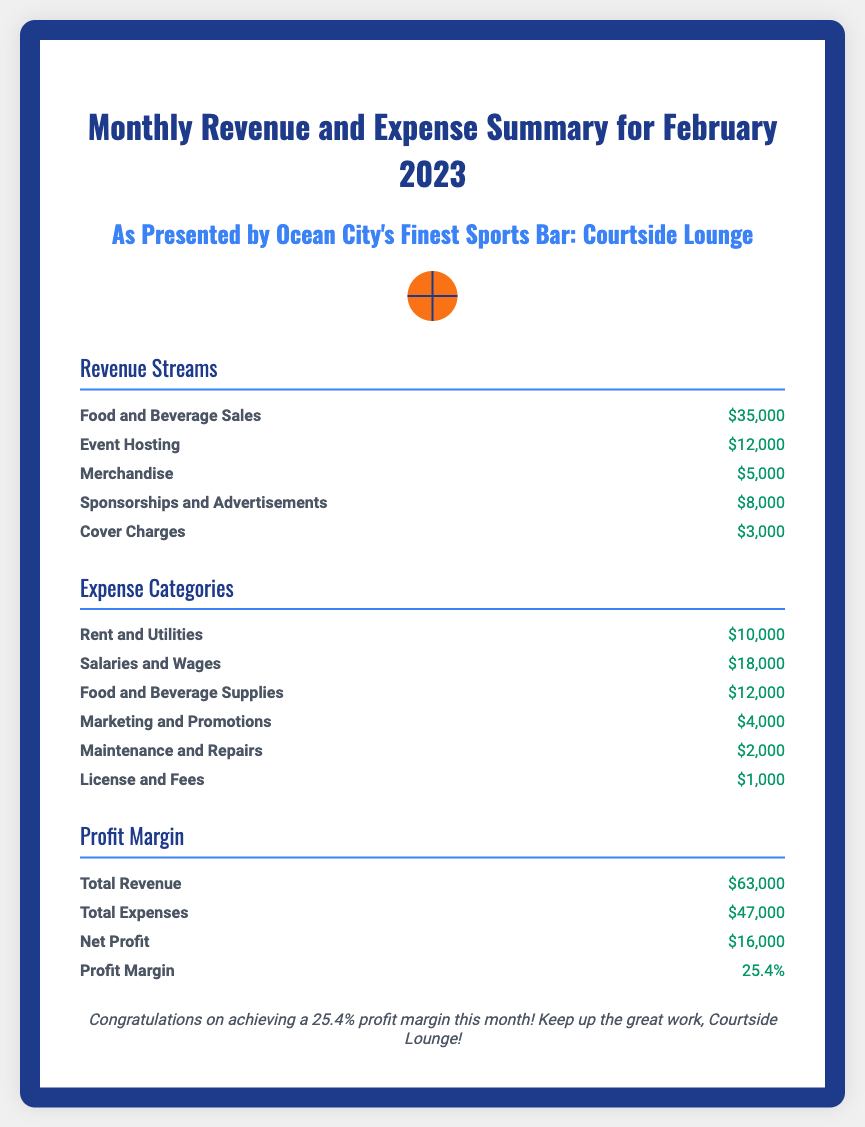what is the total revenue? The total revenue is the sum of all revenue streams listed in the document: $35,000 + $12,000 + $5,000 + $8,000 + $3,000 = $63,000.
Answer: $63,000 what was the expense for Rent and Utilities? The document specifies that the expense for Rent and Utilities is $10,000.
Answer: $10,000 how much was earned from Event Hosting? The amount earned from Event Hosting is clearly stated in the revenue section as $12,000.
Answer: $12,000 what is the net profit for February 2023? The net profit is the difference between total revenue and total expenses, which is $63,000 - $47,000 = $16,000.
Answer: $16,000 what is the profit margin percentage? The document states that the profit margin is 25.4%, indicating the profitability of the bar.
Answer: 25.4% what is the total expense amount? The total expenses are calculated as the sum of all expense categories detailed in the document, which equals $47,000.
Answer: $47,000 which revenue stream generated the highest income? Based on the revenue section, Food and Beverage Sales generated the highest income of $35,000.
Answer: Food and Beverage Sales how much was spent on Marketing and Promotions? The document notes that expenditures on Marketing and Promotions amount to $4,000.
Answer: $4,000 how many revenue streams are listed? The document lists a total of five different revenue streams contributing to the overall income of the bar.
Answer: 5 